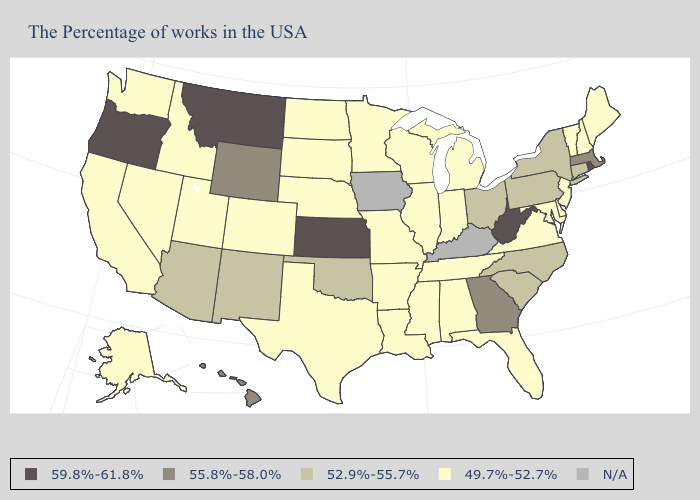Does Missouri have the lowest value in the MidWest?
Keep it brief. Yes. Name the states that have a value in the range 52.9%-55.7%?
Give a very brief answer. Connecticut, New York, Pennsylvania, North Carolina, South Carolina, Ohio, Oklahoma, New Mexico, Arizona. Among the states that border Arizona , does New Mexico have the highest value?
Give a very brief answer. Yes. What is the lowest value in states that border Minnesota?
Short answer required. 49.7%-52.7%. What is the highest value in states that border Louisiana?
Write a very short answer. 49.7%-52.7%. Does North Carolina have the highest value in the USA?
Keep it brief. No. Does the map have missing data?
Keep it brief. Yes. What is the value of Utah?
Short answer required. 49.7%-52.7%. Does Delaware have the lowest value in the USA?
Write a very short answer. Yes. What is the value of South Dakota?
Give a very brief answer. 49.7%-52.7%. What is the value of Hawaii?
Short answer required. 55.8%-58.0%. What is the lowest value in the USA?
Short answer required. 49.7%-52.7%. Does Mississippi have the highest value in the South?
Write a very short answer. No. Among the states that border Alabama , does Georgia have the lowest value?
Give a very brief answer. No. 